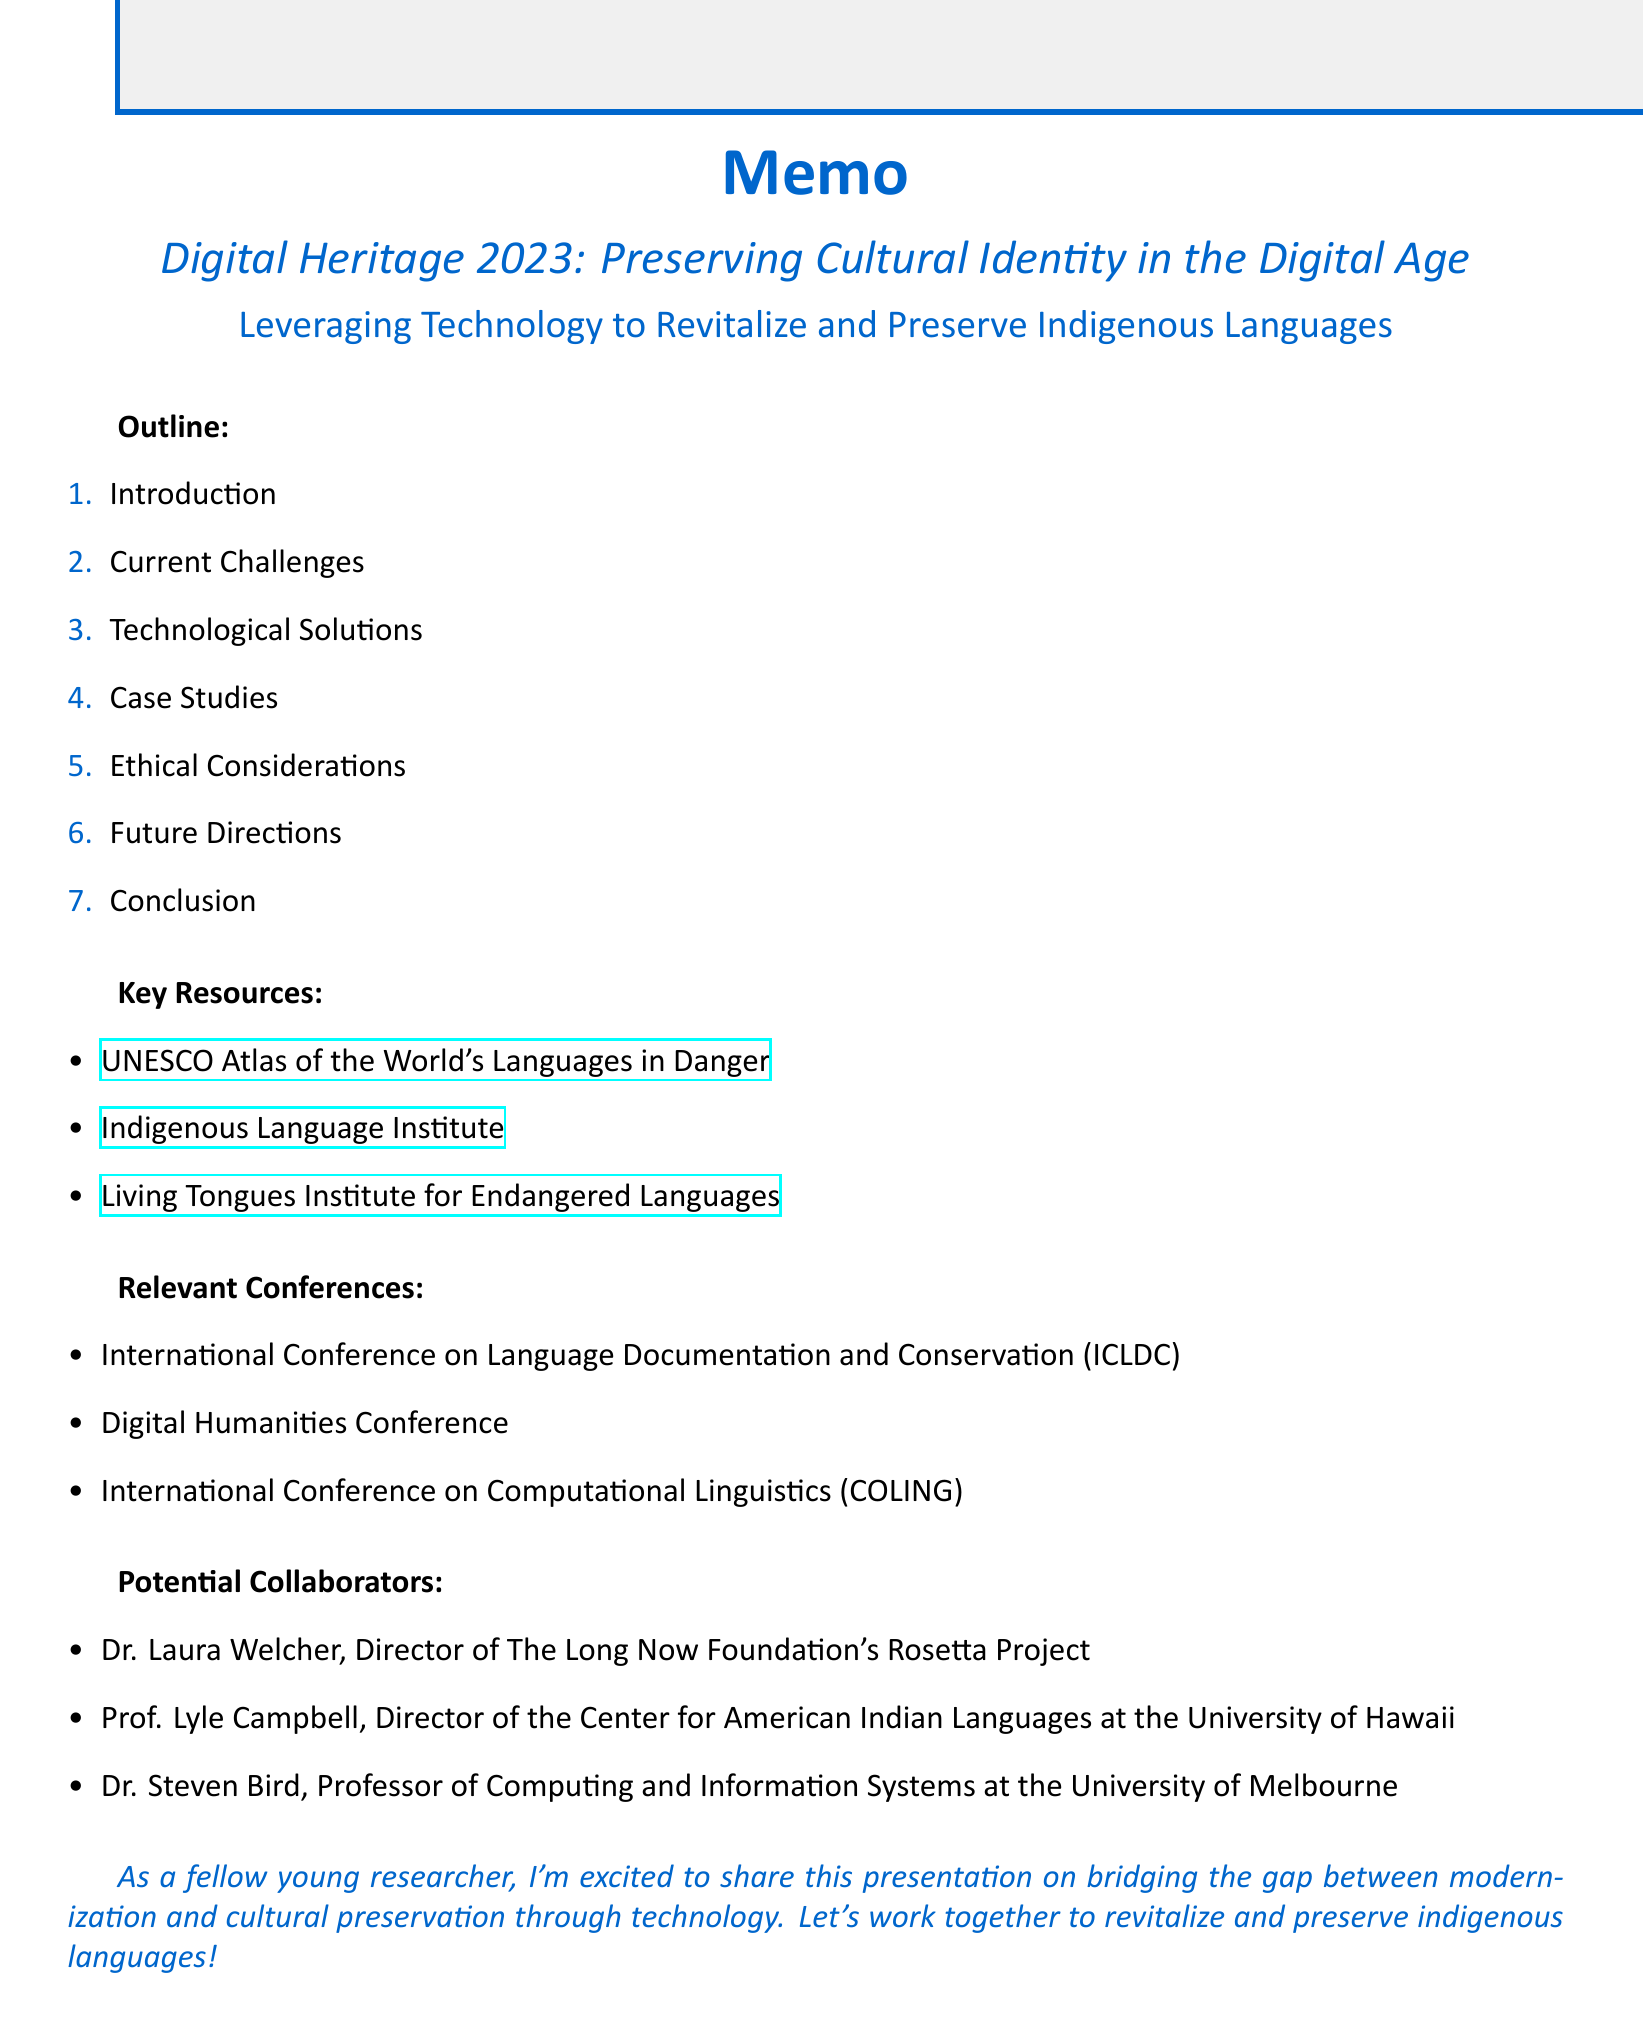What is the title of the conference? The title is clearly stated at the beginning of the document under the conference title section.
Answer: Digital Heritage 2023: Preserving Cultural Identity in the Digital Age What is one key resource mentioned? The document lists several key resources, as shown in the key resources section.
Answer: UNESCO Atlas of the World's Languages in Danger Who is the director of the Center for American Indian Languages? This information is provided in the potential collaborators section, indicating the leadership of a related institute.
Answer: Prof. Lyle Campbell What technological solution is used for immersive language experiences? The outline includes examples of technological solutions that address language preservation.
Answer: Virtual and Augmented Reality What is a major challenge outlined in the presentation? The current challenges section details several issues faced in language preservation.
Answer: Limited resources for language documentation What is the first point in the introduction section? The outline structure lists points under each section, including the introduction.
Answer: Brief overview of the global decline in indigenous languages How many sections are in the outline? The number of sections is explicitly indicated in the outline count.
Answer: Seven What future direction involves personalized language learning? Future directions contains points for upcoming technological developments related to language.
Answer: Integration of AI for personalized language learning 